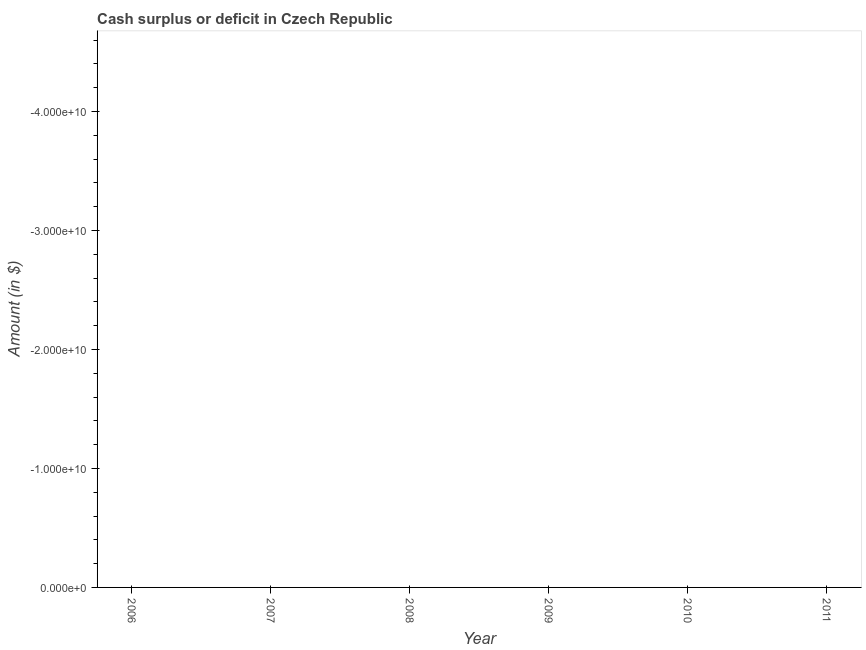What is the sum of the cash surplus or deficit?
Your answer should be compact. 0. What is the median cash surplus or deficit?
Ensure brevity in your answer.  0. In how many years, is the cash surplus or deficit greater than the average cash surplus or deficit taken over all years?
Ensure brevity in your answer.  0. How many dotlines are there?
Ensure brevity in your answer.  0. What is the difference between two consecutive major ticks on the Y-axis?
Provide a short and direct response. 1.00e+1. Are the values on the major ticks of Y-axis written in scientific E-notation?
Provide a succinct answer. Yes. Does the graph contain any zero values?
Your answer should be compact. Yes. What is the title of the graph?
Provide a short and direct response. Cash surplus or deficit in Czech Republic. What is the label or title of the Y-axis?
Your answer should be very brief. Amount (in $). What is the Amount (in $) in 2006?
Keep it short and to the point. 0. What is the Amount (in $) in 2008?
Ensure brevity in your answer.  0. What is the Amount (in $) in 2009?
Keep it short and to the point. 0. What is the Amount (in $) in 2010?
Offer a terse response. 0. 